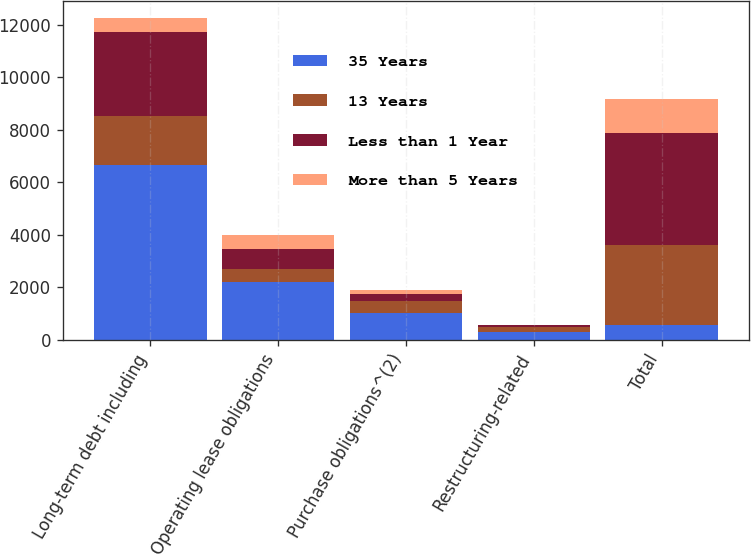Convert chart to OTSL. <chart><loc_0><loc_0><loc_500><loc_500><stacked_bar_chart><ecel><fcel>Long-term debt including<fcel>Operating lease obligations<fcel>Purchase obligations^(2)<fcel>Restructuring-related<fcel>Total<nl><fcel>35 Years<fcel>6668<fcel>2181<fcel>1007<fcel>294<fcel>565<nl><fcel>13 Years<fcel>1861<fcel>521<fcel>452<fcel>195<fcel>3029<nl><fcel>Less than 1 Year<fcel>3175<fcel>759<fcel>287<fcel>59<fcel>4280<nl><fcel>More than 5 Years<fcel>565<fcel>541<fcel>150<fcel>23<fcel>1279<nl></chart> 